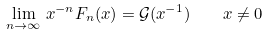Convert formula to latex. <formula><loc_0><loc_0><loc_500><loc_500>\lim _ { n \to \infty } \, x ^ { - n } F _ { n } ( x ) = \mathcal { G } ( x ^ { - 1 } ) \quad x \neq 0</formula> 